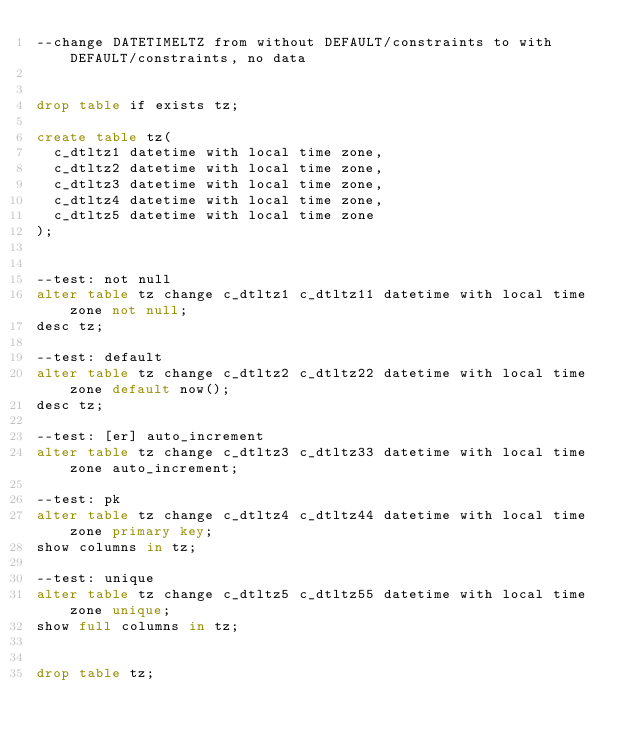<code> <loc_0><loc_0><loc_500><loc_500><_SQL_>--change DATETIMELTZ from without DEFAULT/constraints to with DEFAULT/constraints, no data


drop table if exists tz;

create table tz(
	c_dtltz1 datetime with local time zone,
	c_dtltz2 datetime with local time zone,
	c_dtltz3 datetime with local time zone,
	c_dtltz4 datetime with local time zone,
	c_dtltz5 datetime with local time zone
);


--test: not null
alter table tz change c_dtltz1 c_dtltz11 datetime with local time zone not null;
desc tz;

--test: default
alter table tz change c_dtltz2 c_dtltz22 datetime with local time zone default now();
desc tz;

--test: [er] auto_increment
alter table tz change c_dtltz3 c_dtltz33 datetime with local time zone auto_increment;

--test: pk
alter table tz change c_dtltz4 c_dtltz44 datetime with local time zone primary key;
show columns in tz;

--test: unique
alter table tz change c_dtltz5 c_dtltz55 datetime with local time zone unique;
show full columns in tz;


drop table tz;


</code> 